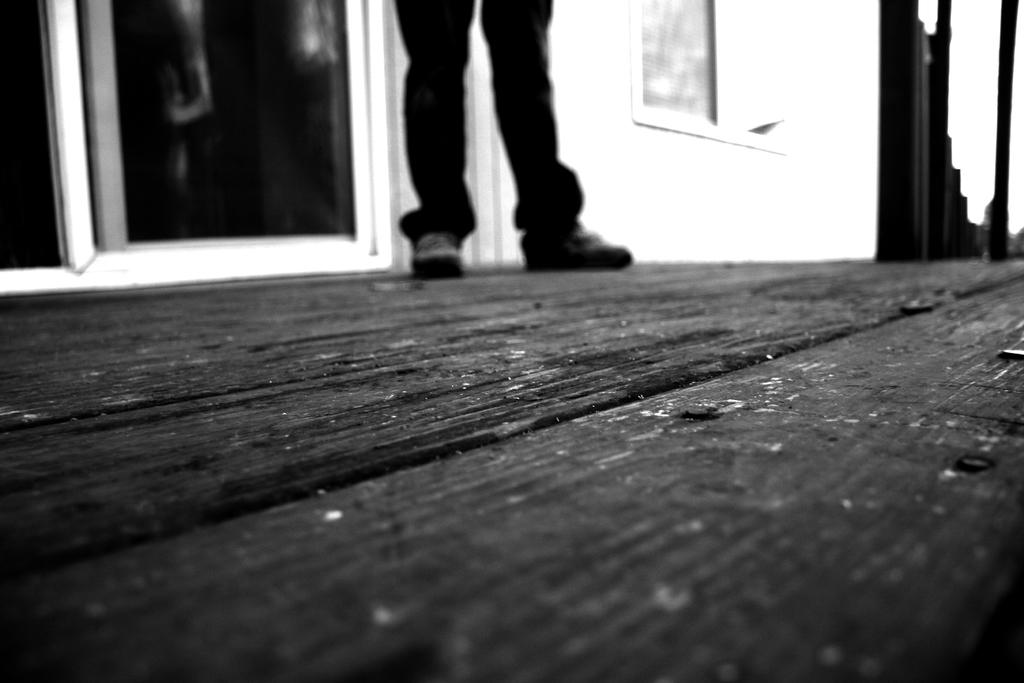What part of a person can be seen in the image? There are legs of a person in the image. What type of openings are present in the image? There are doors and a window in the image. What can be seen in the background of the image? There is a wall visible in the background of the image. What type of jam is being spread on the secretary's desk in the image? There is no jam or secretary present in the image. 